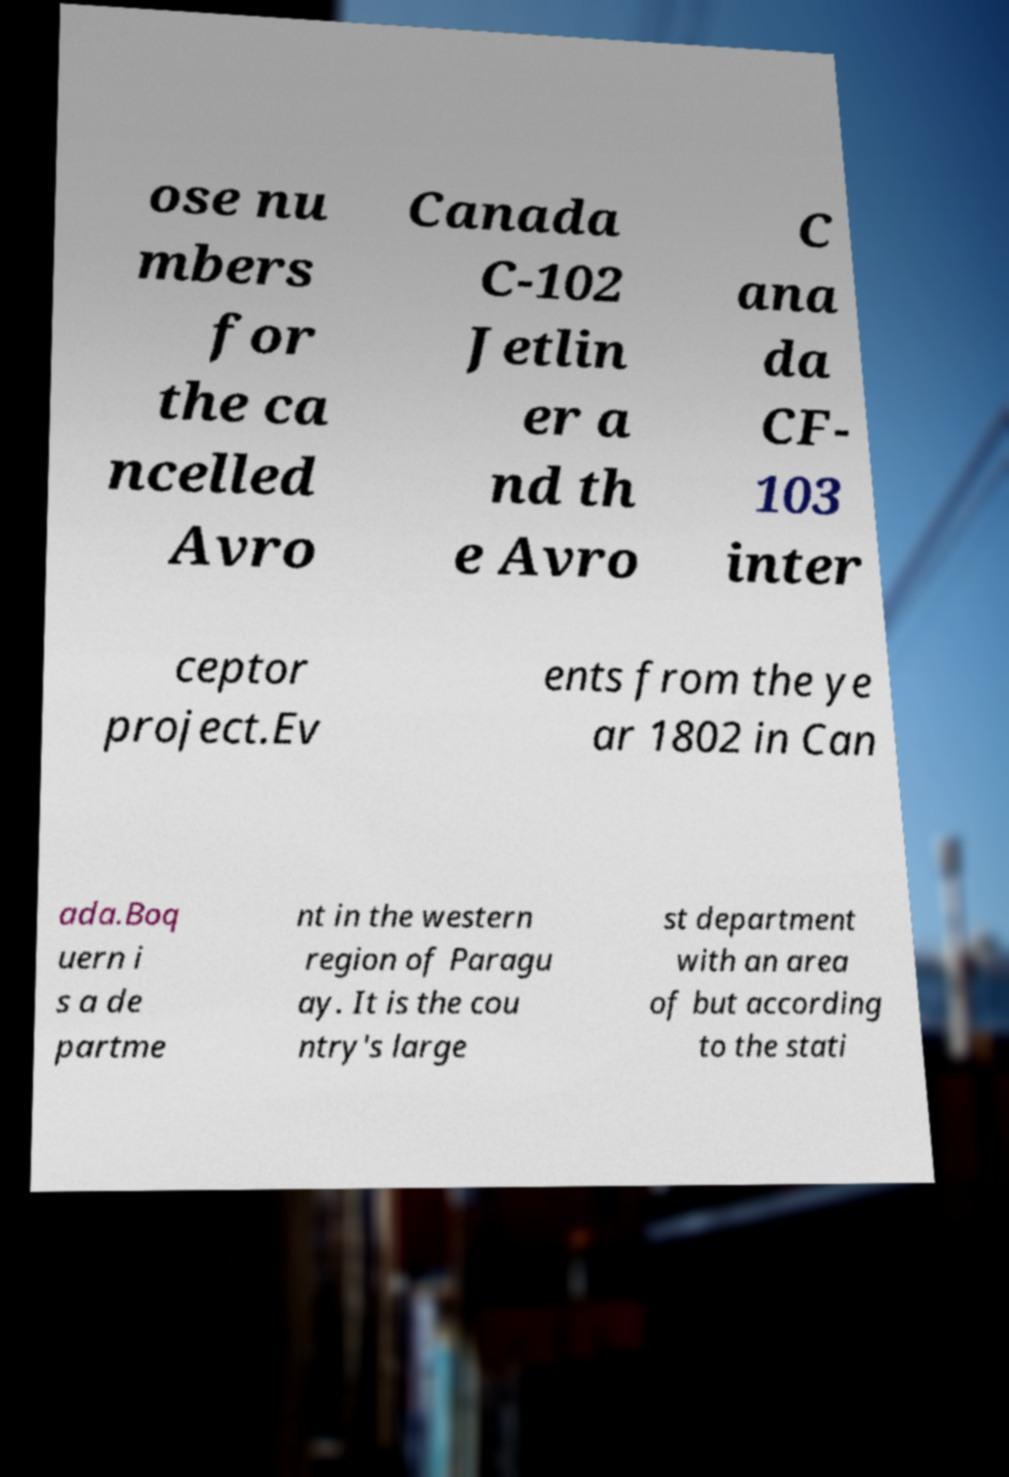For documentation purposes, I need the text within this image transcribed. Could you provide that? ose nu mbers for the ca ncelled Avro Canada C-102 Jetlin er a nd th e Avro C ana da CF- 103 inter ceptor project.Ev ents from the ye ar 1802 in Can ada.Boq uern i s a de partme nt in the western region of Paragu ay. It is the cou ntry's large st department with an area of but according to the stati 